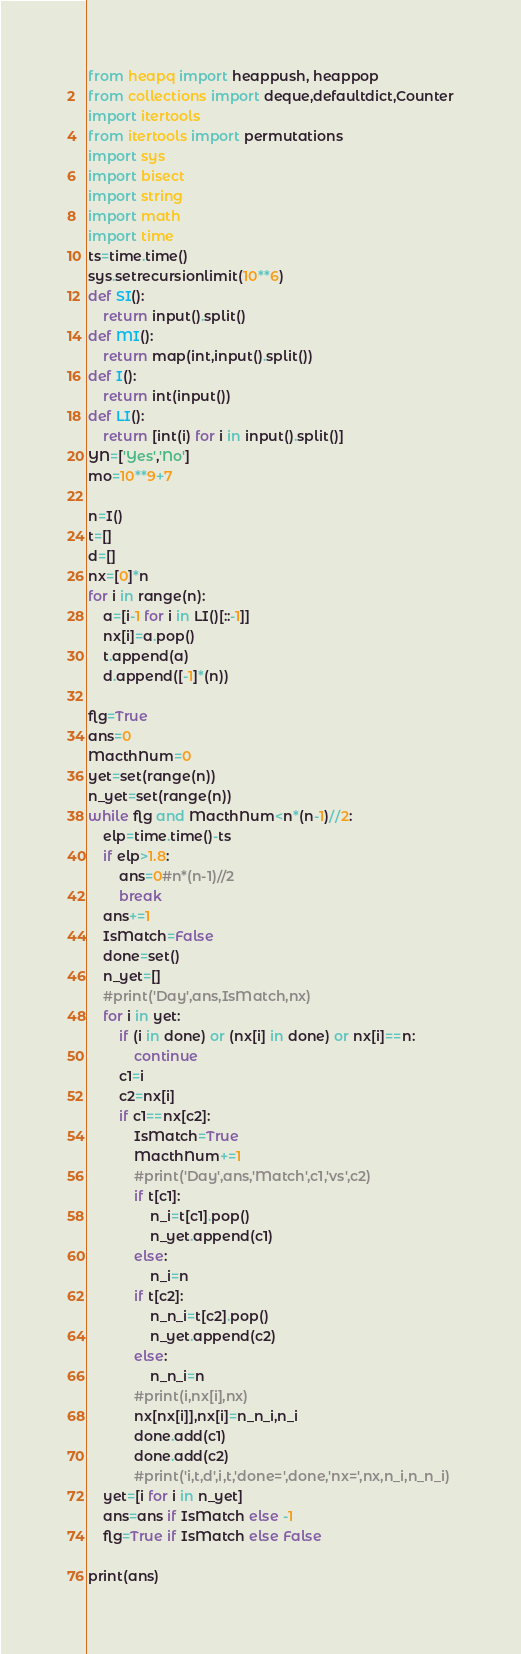Convert code to text. <code><loc_0><loc_0><loc_500><loc_500><_Python_>from heapq import heappush, heappop
from collections import deque,defaultdict,Counter
import itertools
from itertools import permutations
import sys
import bisect
import string
import math
import time
ts=time.time()
sys.setrecursionlimit(10**6)
def SI():
    return input().split()
def MI():
    return map(int,input().split())
def I():
    return int(input())
def LI():
    return [int(i) for i in input().split()]
YN=['Yes','No']
mo=10**9+7

n=I()
t=[]
d=[]
nx=[0]*n
for i in range(n):
    a=[i-1 for i in LI()[::-1]]
    nx[i]=a.pop()
    t.append(a)
    d.append([-1]*(n))

flg=True
ans=0
MacthNum=0
yet=set(range(n))
n_yet=set(range(n))
while flg and MacthNum<n*(n-1)//2:
    elp=time.time()-ts
    if elp>1.8:
        ans=0#n*(n-1)//2
        break
    ans+=1
    IsMatch=False
    done=set()
    n_yet=[]
    #print('Day',ans,IsMatch,nx)
    for i in yet:
        if (i in done) or (nx[i] in done) or nx[i]==n:
            continue
        c1=i
        c2=nx[i]
        if c1==nx[c2]:
            IsMatch=True
            MacthNum+=1
            #print('Day',ans,'Match',c1,'vs',c2)
            if t[c1]:
                n_i=t[c1].pop()
                n_yet.append(c1)
            else:
                n_i=n
            if t[c2]:
                n_n_i=t[c2].pop()
                n_yet.append(c2)
            else:
                n_n_i=n
            #print(i,nx[i],nx)
            nx[nx[i]],nx[i]=n_n_i,n_i
            done.add(c1)
            done.add(c2)
            #print('i,t,d',i,t,'done=',done,'nx=',nx,n_i,n_n_i)
    yet=[i for i in n_yet]
    ans=ans if IsMatch else -1
    flg=True if IsMatch else False

print(ans)
</code> 